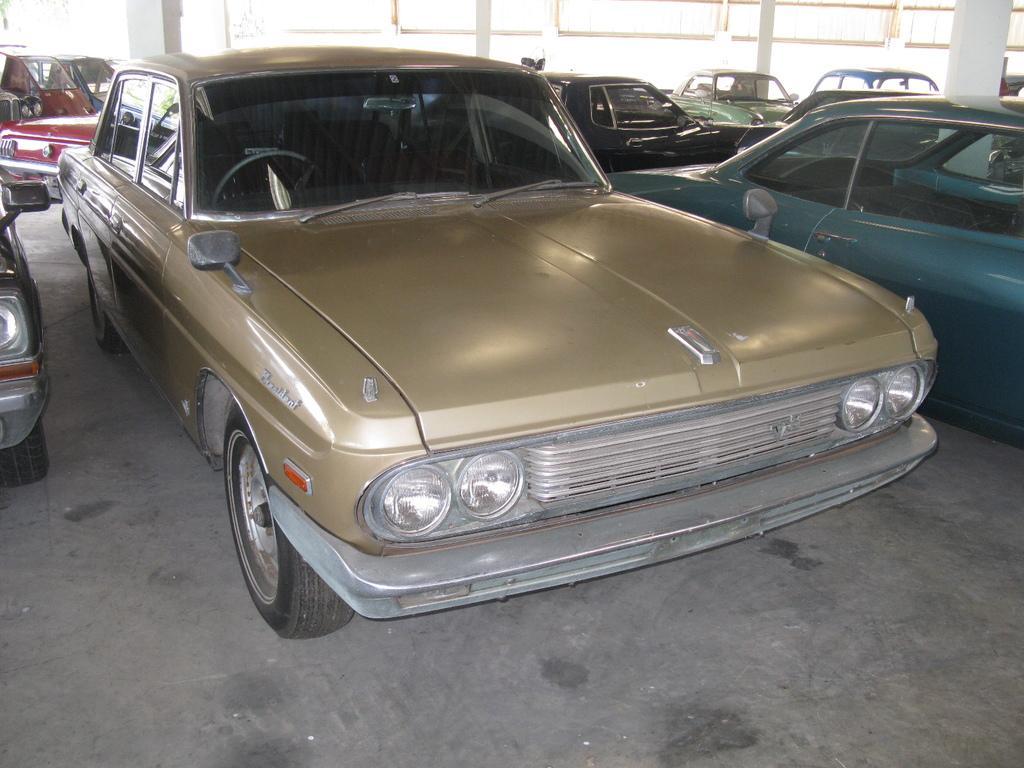How would you summarize this image in a sentence or two? In the picture I can see gold color car and a few more cars which are on the either side and in the background. Also, we can see light and pillars. 